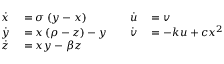<formula> <loc_0><loc_0><loc_500><loc_500>\begin{array} { r l r l } { \dot { x } } & = \sigma \left ( y - x \right ) \quad } & { \dot { u } } & = v } \\ { \dot { y } } & = x \left ( \rho - z \right ) - y \quad } & { \dot { v } } & = - k u + c x ^ { 2 } } \\ { \dot { z } } & = x y - \beta } \end{array}</formula> 